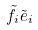Convert formula to latex. <formula><loc_0><loc_0><loc_500><loc_500>\tilde { f } _ { i } \tilde { e } _ { i }</formula> 